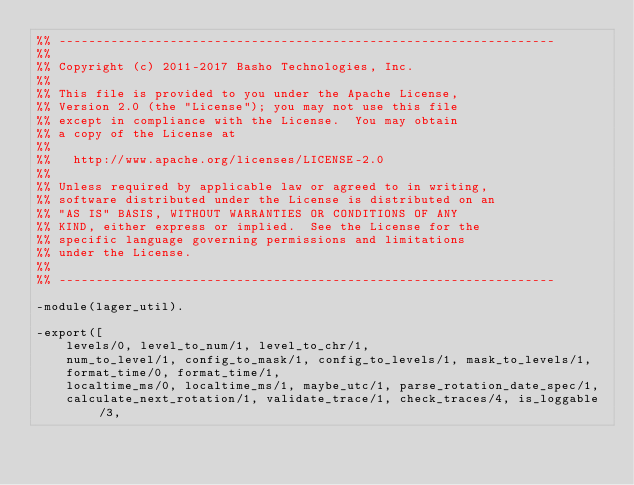Convert code to text. <code><loc_0><loc_0><loc_500><loc_500><_Erlang_>%% -------------------------------------------------------------------
%%
%% Copyright (c) 2011-2017 Basho Technologies, Inc.
%%
%% This file is provided to you under the Apache License,
%% Version 2.0 (the "License"); you may not use this file
%% except in compliance with the License.  You may obtain
%% a copy of the License at
%%
%%   http://www.apache.org/licenses/LICENSE-2.0
%%
%% Unless required by applicable law or agreed to in writing,
%% software distributed under the License is distributed on an
%% "AS IS" BASIS, WITHOUT WARRANTIES OR CONDITIONS OF ANY
%% KIND, either express or implied.  See the License for the
%% specific language governing permissions and limitations
%% under the License.
%%
%% -------------------------------------------------------------------

-module(lager_util).

-export([
    levels/0, level_to_num/1, level_to_chr/1,
    num_to_level/1, config_to_mask/1, config_to_levels/1, mask_to_levels/1,
    format_time/0, format_time/1,
    localtime_ms/0, localtime_ms/1, maybe_utc/1, parse_rotation_date_spec/1,
    calculate_next_rotation/1, validate_trace/1, check_traces/4, is_loggable/3,</code> 